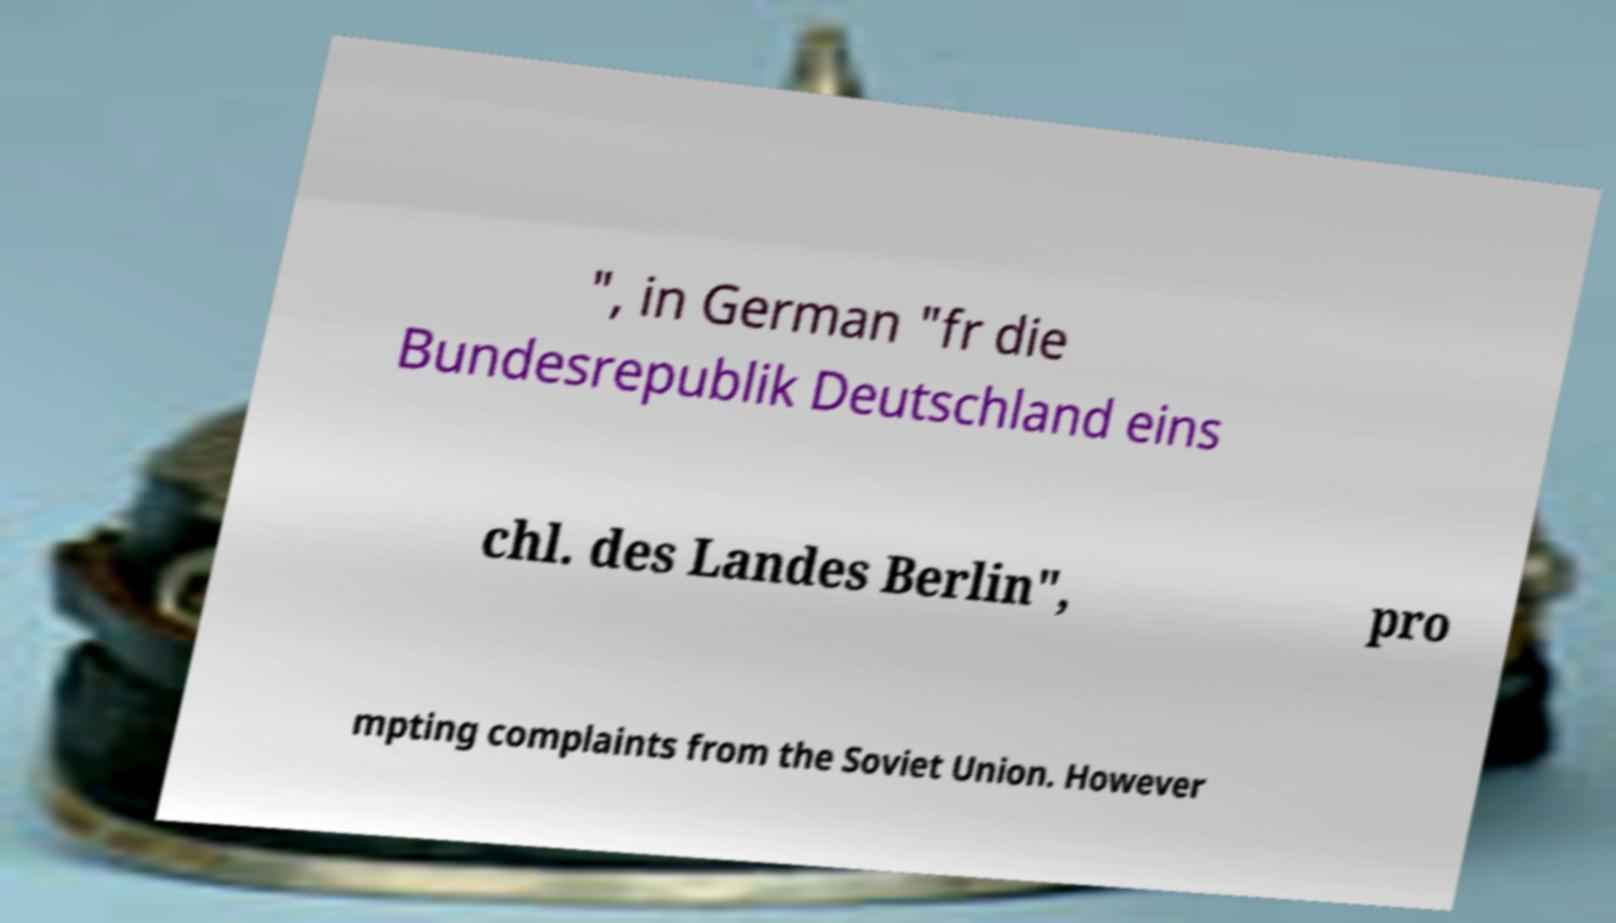Can you accurately transcribe the text from the provided image for me? ", in German "fr die Bundesrepublik Deutschland eins chl. des Landes Berlin", pro mpting complaints from the Soviet Union. However 